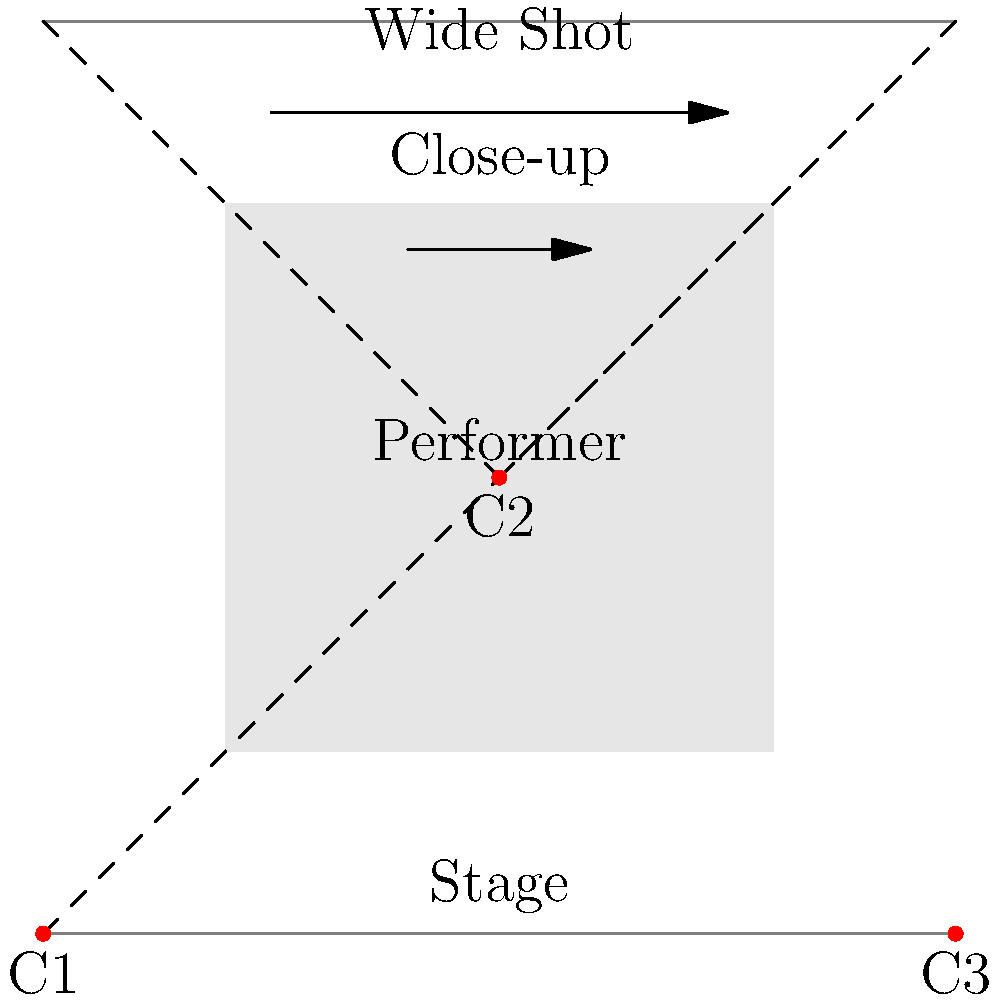In the iconic jazz club scene from the film "Whiplash," analyze how the director uses camera angles and shot compositions to enhance the emotional intensity of the drummer's performance. How do these techniques contribute to the audience's perception of the musician's struggle and determination? 1. Camera Angles:
   a) Low-angle shots (C1): The drummer is often shown from a low angle, making him appear more powerful and dominant. This emphasizes his determination and the intensity of his performance.
   b) Eye-level shots (C2): Used for dialogue and interactions, creating a sense of intimacy and allowing the audience to connect with the characters.
   c) High-angle shots (C3): Occasionally used to show the drummer's vulnerability or the pressure he's under, especially when the bandleader is critiquing him.

2. Shot Compositions:
   a) Wide shots: Establish the setting and show the full band, giving context to the performance and the drummer's role within it.
   b) Close-ups: Focus on the drummer's face and hands, revealing his emotions and the physical toll of his intense playing.
   c) Over-the-shoulder shots: Used during interactions between the drummer and the bandleader, emphasizing their power dynamic.

3. Dynamic camera movement:
   a) Whip pans: Quick, jarring camera movements that mirror the frenetic energy of the jazz performance and the drummer's mental state.
   b) Tracking shots: Follow the drummer as he moves, creating a sense of urgency and momentum.

4. Rhythm and editing:
   a) Fast-paced cuts: Match the tempo of the music, increasing tension and excitement.
   b) Longer takes during solos: Allow the audience to fully appreciate the musician's skill and emotional investment.

5. Lighting:
   a) High contrast: Creates dramatic shadows, emphasizing the intensity of the performance and the pressure on the drummer.
   b) Spotlight effects: Draw attention to the drummer during crucial moments, isolating him from his surroundings.

These techniques combine to create a visceral, immersive experience that puts the audience in the drummer's shoes, feeling his struggle, determination, and the high stakes of his performance. The dynamic camera work and varied shot compositions reflect the rhythm and intensity of the jazz music, while also revealing the emotional journey of the protagonist.
Answer: Dynamic camera angles, close-ups, and rhythmic editing intensify the drummer's emotional struggle and determination. 